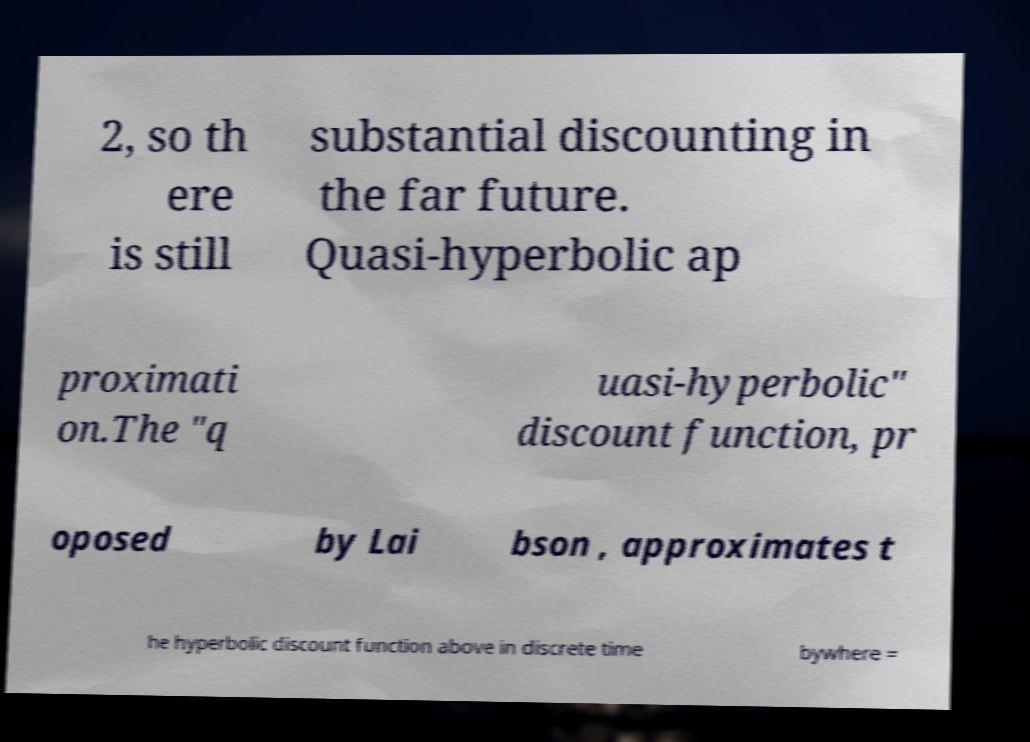Could you assist in decoding the text presented in this image and type it out clearly? 2, so th ere is still substantial discounting in the far future. Quasi-hyperbolic ap proximati on.The "q uasi-hyperbolic" discount function, pr oposed by Lai bson , approximates t he hyperbolic discount function above in discrete time bywhere = 